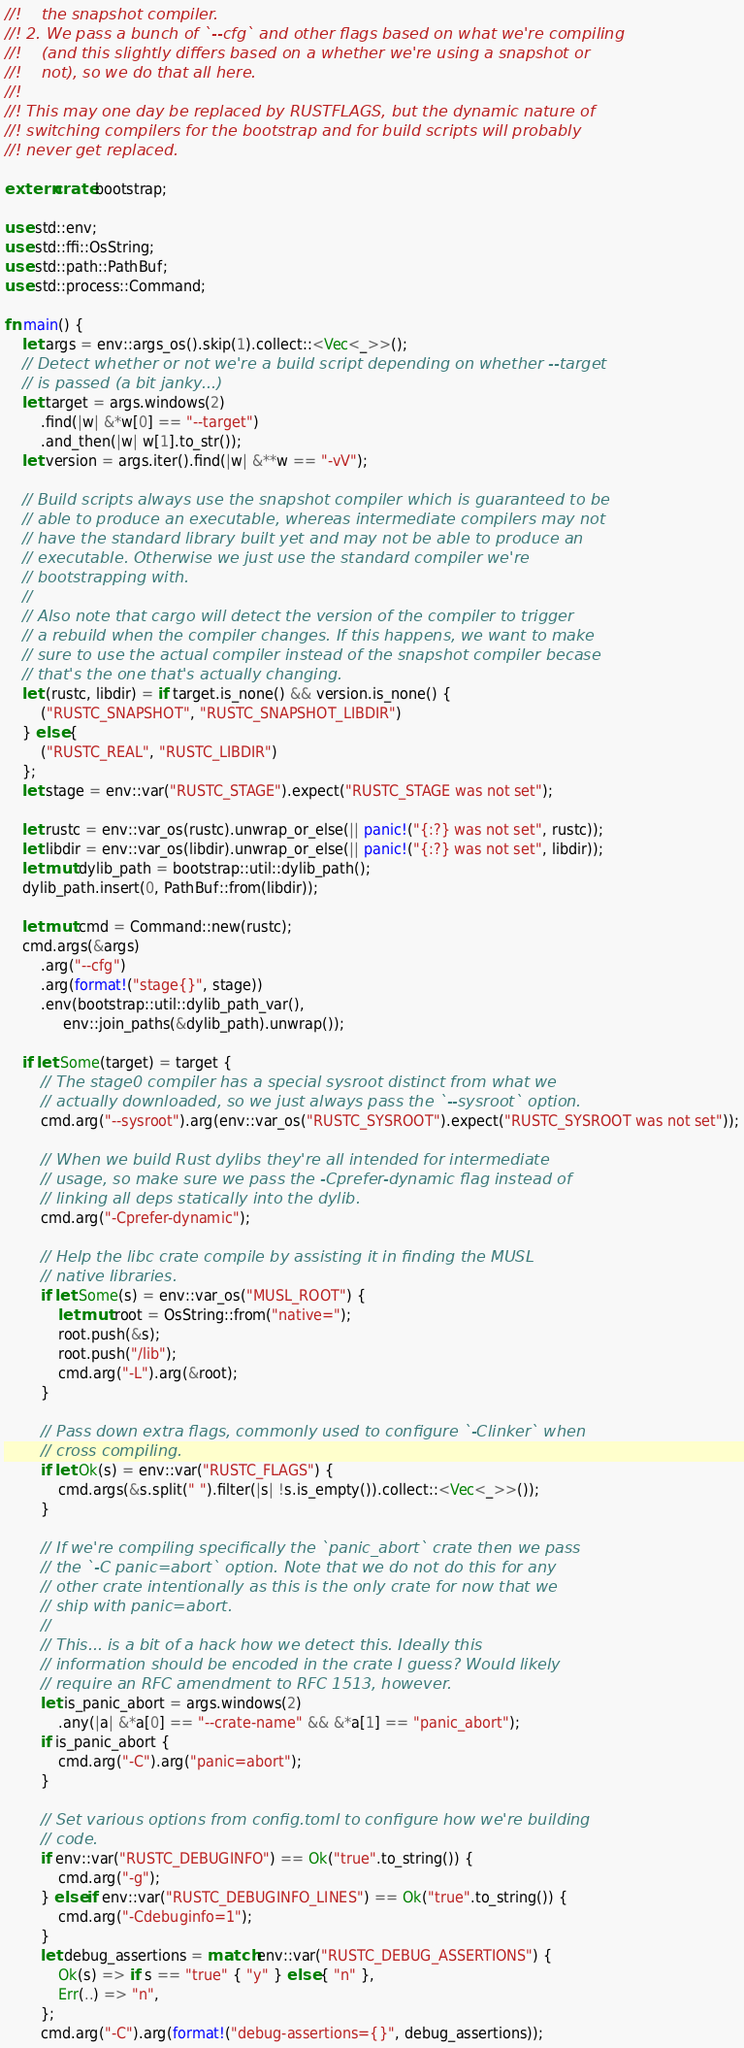Convert code to text. <code><loc_0><loc_0><loc_500><loc_500><_Rust_>//!    the snapshot compiler.
//! 2. We pass a bunch of `--cfg` and other flags based on what we're compiling
//!    (and this slightly differs based on a whether we're using a snapshot or
//!    not), so we do that all here.
//!
//! This may one day be replaced by RUSTFLAGS, but the dynamic nature of
//! switching compilers for the bootstrap and for build scripts will probably
//! never get replaced.

extern crate bootstrap;

use std::env;
use std::ffi::OsString;
use std::path::PathBuf;
use std::process::Command;

fn main() {
    let args = env::args_os().skip(1).collect::<Vec<_>>();
    // Detect whether or not we're a build script depending on whether --target
    // is passed (a bit janky...)
    let target = args.windows(2)
        .find(|w| &*w[0] == "--target")
        .and_then(|w| w[1].to_str());
    let version = args.iter().find(|w| &**w == "-vV");

    // Build scripts always use the snapshot compiler which is guaranteed to be
    // able to produce an executable, whereas intermediate compilers may not
    // have the standard library built yet and may not be able to produce an
    // executable. Otherwise we just use the standard compiler we're
    // bootstrapping with.
    //
    // Also note that cargo will detect the version of the compiler to trigger
    // a rebuild when the compiler changes. If this happens, we want to make
    // sure to use the actual compiler instead of the snapshot compiler becase
    // that's the one that's actually changing.
    let (rustc, libdir) = if target.is_none() && version.is_none() {
        ("RUSTC_SNAPSHOT", "RUSTC_SNAPSHOT_LIBDIR")
    } else {
        ("RUSTC_REAL", "RUSTC_LIBDIR")
    };
    let stage = env::var("RUSTC_STAGE").expect("RUSTC_STAGE was not set");

    let rustc = env::var_os(rustc).unwrap_or_else(|| panic!("{:?} was not set", rustc));
    let libdir = env::var_os(libdir).unwrap_or_else(|| panic!("{:?} was not set", libdir));
    let mut dylib_path = bootstrap::util::dylib_path();
    dylib_path.insert(0, PathBuf::from(libdir));

    let mut cmd = Command::new(rustc);
    cmd.args(&args)
        .arg("--cfg")
        .arg(format!("stage{}", stage))
        .env(bootstrap::util::dylib_path_var(),
             env::join_paths(&dylib_path).unwrap());

    if let Some(target) = target {
        // The stage0 compiler has a special sysroot distinct from what we
        // actually downloaded, so we just always pass the `--sysroot` option.
        cmd.arg("--sysroot").arg(env::var_os("RUSTC_SYSROOT").expect("RUSTC_SYSROOT was not set"));

        // When we build Rust dylibs they're all intended for intermediate
        // usage, so make sure we pass the -Cprefer-dynamic flag instead of
        // linking all deps statically into the dylib.
        cmd.arg("-Cprefer-dynamic");

        // Help the libc crate compile by assisting it in finding the MUSL
        // native libraries.
        if let Some(s) = env::var_os("MUSL_ROOT") {
            let mut root = OsString::from("native=");
            root.push(&s);
            root.push("/lib");
            cmd.arg("-L").arg(&root);
        }

        // Pass down extra flags, commonly used to configure `-Clinker` when
        // cross compiling.
        if let Ok(s) = env::var("RUSTC_FLAGS") {
            cmd.args(&s.split(" ").filter(|s| !s.is_empty()).collect::<Vec<_>>());
        }

        // If we're compiling specifically the `panic_abort` crate then we pass
        // the `-C panic=abort` option. Note that we do not do this for any
        // other crate intentionally as this is the only crate for now that we
        // ship with panic=abort.
        //
        // This... is a bit of a hack how we detect this. Ideally this
        // information should be encoded in the crate I guess? Would likely
        // require an RFC amendment to RFC 1513, however.
        let is_panic_abort = args.windows(2)
            .any(|a| &*a[0] == "--crate-name" && &*a[1] == "panic_abort");
        if is_panic_abort {
            cmd.arg("-C").arg("panic=abort");
        }

        // Set various options from config.toml to configure how we're building
        // code.
        if env::var("RUSTC_DEBUGINFO") == Ok("true".to_string()) {
            cmd.arg("-g");
        } else if env::var("RUSTC_DEBUGINFO_LINES") == Ok("true".to_string()) {
            cmd.arg("-Cdebuginfo=1");
        }
        let debug_assertions = match env::var("RUSTC_DEBUG_ASSERTIONS") {
            Ok(s) => if s == "true" { "y" } else { "n" },
            Err(..) => "n",
        };
        cmd.arg("-C").arg(format!("debug-assertions={}", debug_assertions));</code> 